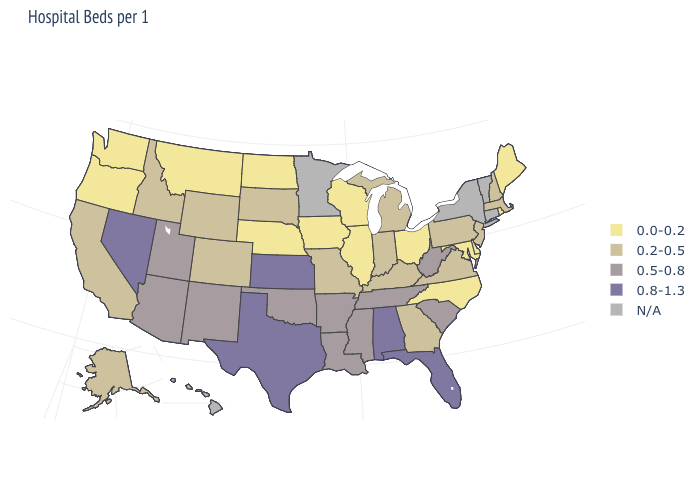What is the value of Colorado?
Write a very short answer. 0.2-0.5. What is the value of New Mexico?
Answer briefly. 0.5-0.8. Which states have the lowest value in the West?
Short answer required. Montana, Oregon, Washington. Name the states that have a value in the range 0.8-1.3?
Write a very short answer. Alabama, Florida, Kansas, Nevada, Texas. Which states have the lowest value in the USA?
Be succinct. Delaware, Illinois, Iowa, Maine, Maryland, Montana, Nebraska, North Carolina, North Dakota, Ohio, Oregon, Rhode Island, Washington, Wisconsin. What is the lowest value in the South?
Write a very short answer. 0.0-0.2. Does the map have missing data?
Quick response, please. Yes. Name the states that have a value in the range 0.5-0.8?
Short answer required. Arizona, Arkansas, Louisiana, Mississippi, New Mexico, Oklahoma, South Carolina, Tennessee, Utah, West Virginia. Does the map have missing data?
Answer briefly. Yes. Is the legend a continuous bar?
Concise answer only. No. Name the states that have a value in the range 0.2-0.5?
Give a very brief answer. Alaska, California, Colorado, Georgia, Idaho, Indiana, Kentucky, Massachusetts, Michigan, Missouri, New Hampshire, New Jersey, Pennsylvania, South Dakota, Virginia, Wyoming. What is the value of West Virginia?
Quick response, please. 0.5-0.8. What is the lowest value in the USA?
Keep it brief. 0.0-0.2. What is the value of Delaware?
Keep it brief. 0.0-0.2. Name the states that have a value in the range N/A?
Keep it brief. Connecticut, Hawaii, Minnesota, New York, Vermont. 